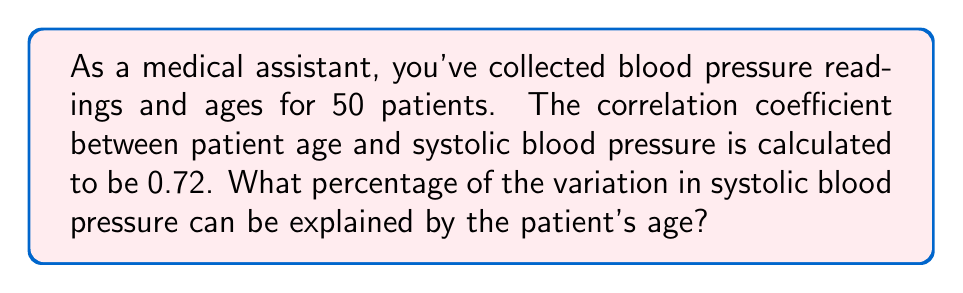Solve this math problem. Let's approach this step-by-step:

1) The correlation coefficient, often denoted as $r$, measures the strength and direction of a linear relationship between two variables. In this case, $r = 0.72$.

2) To determine how much of the variation in one variable can be explained by the other, we use the coefficient of determination, denoted as $R^2$.

3) The coefficient of determination is simply the square of the correlation coefficient:

   $R^2 = r^2$

4) Substituting our value:

   $R^2 = (0.72)^2 = 0.5184$

5) To express this as a percentage, we multiply by 100:

   $0.5184 \times 100 = 51.84\%$

6) Therefore, approximately 51.84% of the variation in systolic blood pressure can be explained by the patient's age.

This means that age accounts for about half of the variability in systolic blood pressure readings, suggesting a moderate to strong relationship between these variables in your patient population.
Answer: 51.84% 